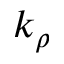Convert formula to latex. <formula><loc_0><loc_0><loc_500><loc_500>k _ { \rho }</formula> 